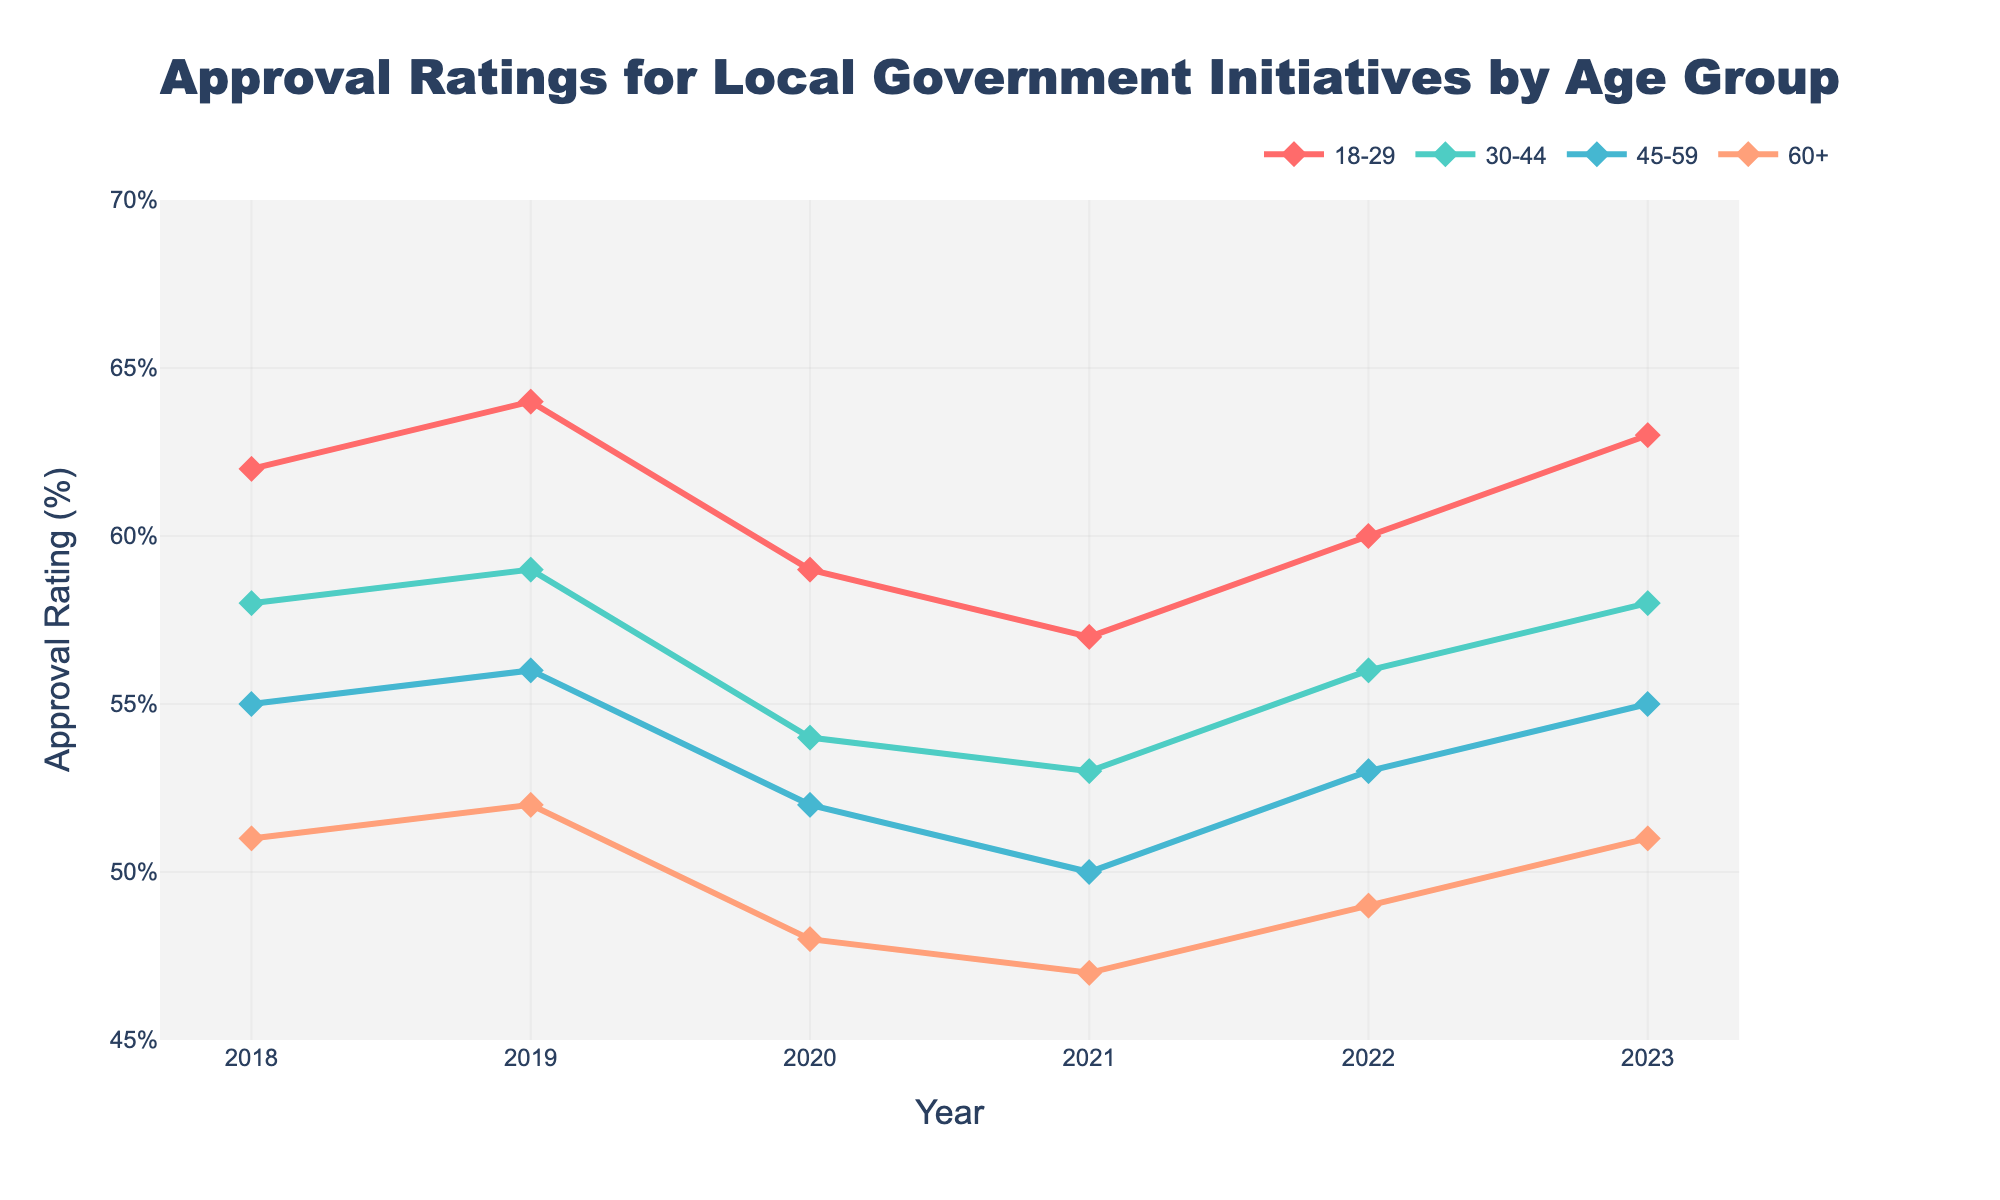What is the approval rating for the 18-29 age group in 2020? Look at the line corresponding to the 18-29 age group and find the value for the year 2020.
Answer: 59% Which age group had the lowest approval rating in 2021? Compare the approval ratings of all age groups for the year 2021. The 60+ age group has the lowest rating.
Answer: 60+ Between 2018 and 2023, which age group showed the greatest increase in approval rating? Calculate the difference between the approval ratings for 2023 and 2018 for each age group. The 18-29 age group increased from 62% to 63%, 30-44 from 58% to 58%, 45-59 from 55% to 55%, and 60+ from 51% to 51%.
Answer: 18-29 What is the average approval rating for the 30-44 age group over the years shown? Sum the approval ratings for the 30-44 age group and divide by the number of years (sum of 58, 59, 54, 53, 56, 58 divided by 6).
Answer: 56.33% In which year did the 45-59 age group have a lower approval rating than the 30-44 age group? Compare approval ratings of the 45-59 and 30-44 age groups for all years. The 45-59 group had lower ratings in 2018, 2019, 2020, and 2021.
Answer: 2018, 2019, 2020, 2021 Which two age groups had the same approval rating in 2023? Look at the approval ratings for all age groups in 2023. The 30-44 and 45-59 age groups both had an approval rating of 58.
Answer: 30-44 and 45-59 How did the approval rating for the 60+ age group change from 2020 to 2021? Find the approval ratings for the 60+ age group in 2020 and 2021, then calculate the difference.
Answer: -1% By how much did the approval rating for the 18-29 age group decline from its peak to its lowest point? Identify the peak (64% in 2019) and the lowest point (57% in 2021), then calculate the difference.
Answer: 7% Which year had the smallest difference in approval ratings between the 18-29 and 60+ age groups? Calculate the differences between the two age groups for each year and find the smallest value. For 2018: 11%, 2019: 12%, 2020: 11%, 2021: 10%, 2022: 11%, 2023: 12%.
Answer: 2021 